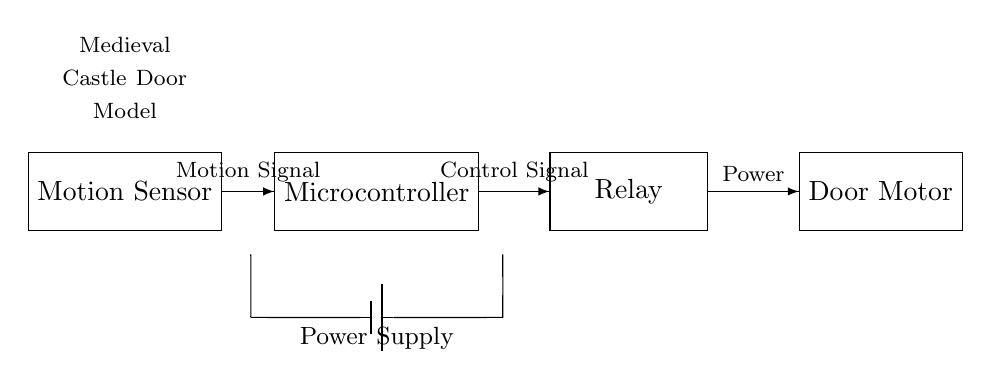What component detects motion? The motion sensor is the component that detects motion in the circuit. It is the first element in the schematic and is responsible for sensing any movement in its vicinity.
Answer: Motion Sensor What activates the relay? The relay is activated by the control signal coming from the microcontroller, which processes input from the motion sensor. When motion is detected, the microcontroller sends a control signal to the relay to initiate the motor.
Answer: Control Signal What type of device is the microcontroller? The microcontroller is a computational device that processes the motion signal from the sensor and sends the appropriate control signal to the relay. It acts as the brain of the circuit, coordinating action based on input.
Answer: Computational Device How does the power flow in this circuit? Power flows from the power supply to the door motor through the relay, which acts as a switch controlled by the microcontroller. The supply first connects to the microcontroller and then to the relay, allowing controlled power to the motor when needed.
Answer: Power Supply to Relay to Motor What role does the motion sensor play? The motion sensor detects any movement and sends a signal to the microcontroller, which determines whether to open the castle door by activating the motor. Its primary function is to initiate the sequence for opening the door based on motion detection.
Answer: Initiates Action What is the final output of the circuit? The final output of the circuit is the operation of the door motor, which opens or closes the medieval castle door based on the control signals processed by the microcontroller from the motion sensor.
Answer: Door Motor Operation What type of circuit is this? This is a control circuit designed for motion activation, where the system operates in response to detected movement and manages the opening of a castle door model remotely.
Answer: Control Circuit 